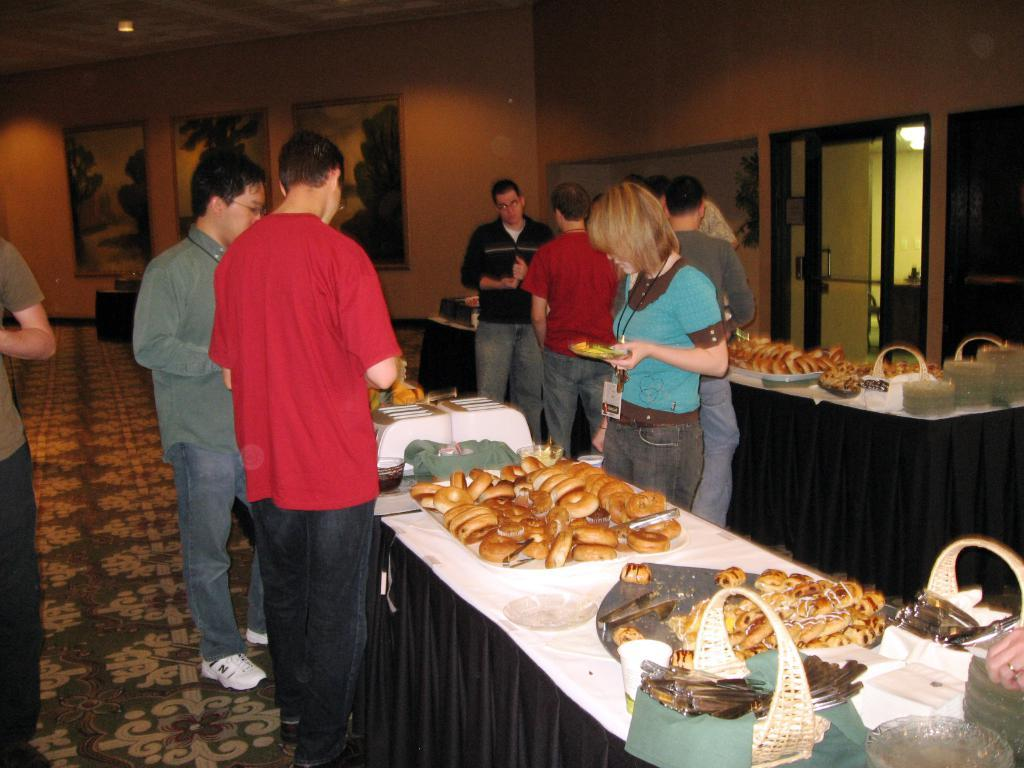What is happening in the image? There are people standing in the image. What objects are present in the image besides the people? There are tables in the image. What is on the tables? There is food on the tables. What can be seen in the background of the image? There is a wall in the background of the image. What is on the wall? There are photo frames on the wall. What type of blade is being used by the farmer in the image? There is no farmer or blade present in the image. How many pins are visible on the wall in the image? There is no mention of pins in the image; only photo frames are mentioned on the wall. 